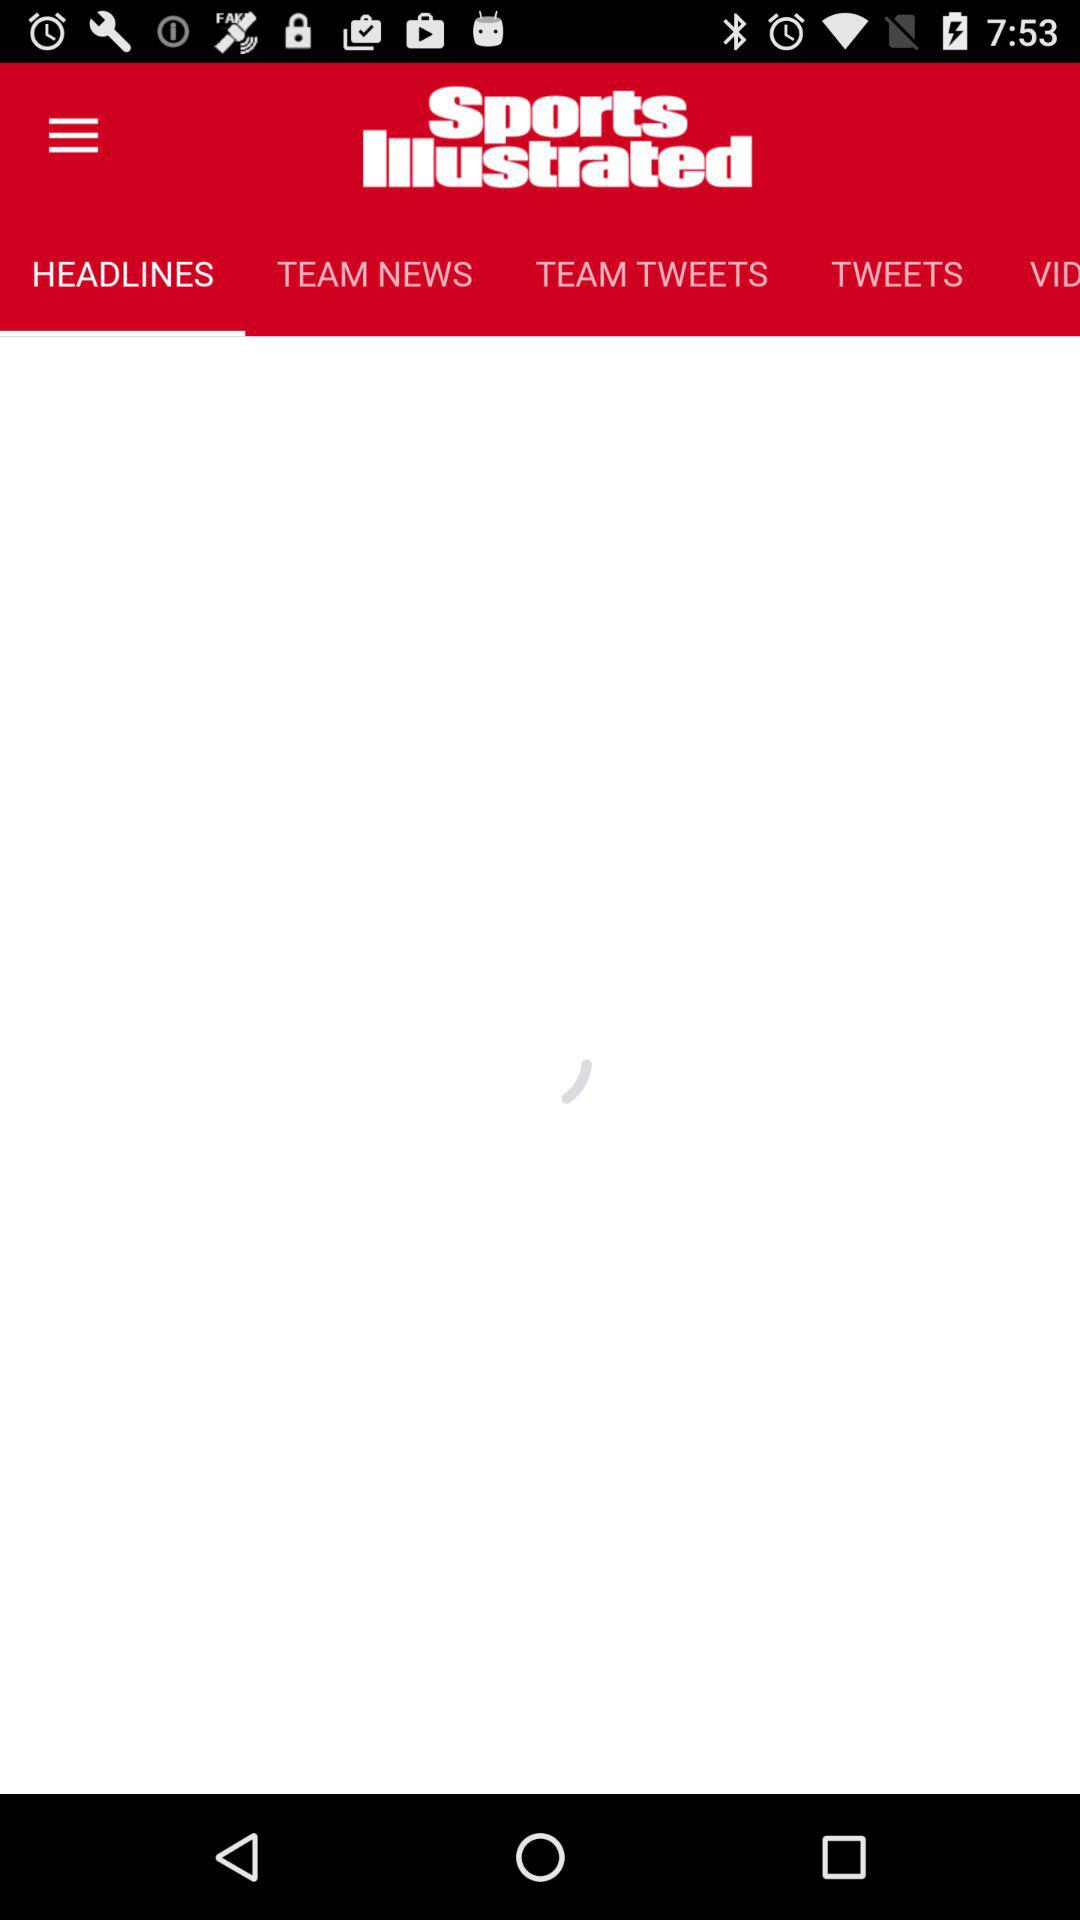What is the application name? The name of the application is "Sports Illustrated". 